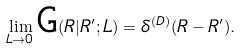Convert formula to latex. <formula><loc_0><loc_0><loc_500><loc_500>\lim _ { L \to 0 } \text {G} ( { R } | { R } ^ { \prime } ; L ) = \delta ^ { ( D ) } ( { R } - { R } ^ { \prime } ) .</formula> 